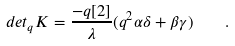Convert formula to latex. <formula><loc_0><loc_0><loc_500><loc_500>d e t _ { q } K = \frac { - q [ 2 ] } { \lambda } ( q ^ { 2 } \alpha \delta + \beta \gamma ) \quad .</formula> 